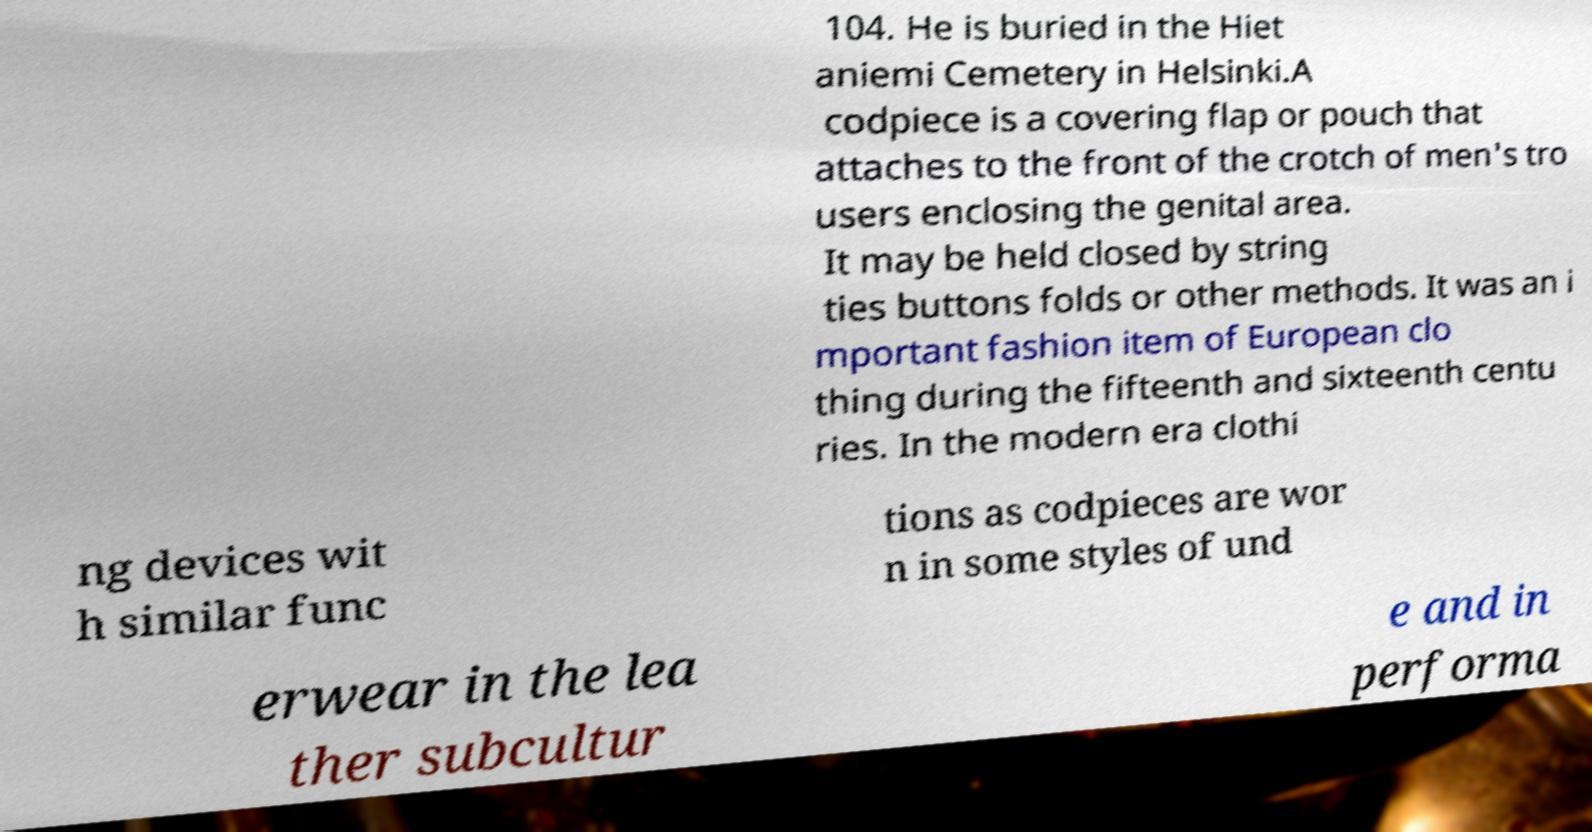Can you accurately transcribe the text from the provided image for me? 104. He is buried in the Hiet aniemi Cemetery in Helsinki.A codpiece is a covering flap or pouch that attaches to the front of the crotch of men's tro users enclosing the genital area. It may be held closed by string ties buttons folds or other methods. It was an i mportant fashion item of European clo thing during the fifteenth and sixteenth centu ries. In the modern era clothi ng devices wit h similar func tions as codpieces are wor n in some styles of und erwear in the lea ther subcultur e and in performa 